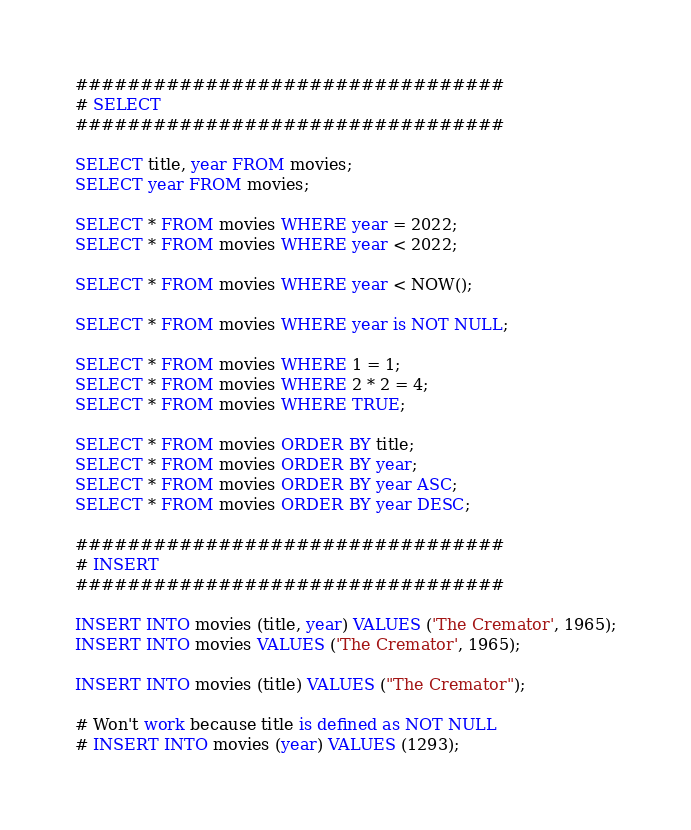<code> <loc_0><loc_0><loc_500><loc_500><_SQL_>#################################
# SELECT
#################################

SELECT title, year FROM movies;
SELECT year FROM movies;

SELECT * FROM movies WHERE year = 2022;
SELECT * FROM movies WHERE year < 2022;

SELECT * FROM movies WHERE year < NOW();

SELECT * FROM movies WHERE year is NOT NULL;

SELECT * FROM movies WHERE 1 = 1;
SELECT * FROM movies WHERE 2 * 2 = 4;
SELECT * FROM movies WHERE TRUE;

SELECT * FROM movies ORDER BY title;
SELECT * FROM movies ORDER BY year;
SELECT * FROM movies ORDER BY year ASC;
SELECT * FROM movies ORDER BY year DESC;

#################################
# INSERT
#################################

INSERT INTO movies (title, year) VALUES ('The Cremator', 1965);
INSERT INTO movies VALUES ('The Cremator', 1965);

INSERT INTO movies (title) VALUES ("The Cremator");

# Won't work because title is defined as NOT NULL
# INSERT INTO movies (year) VALUES (1293);</code> 